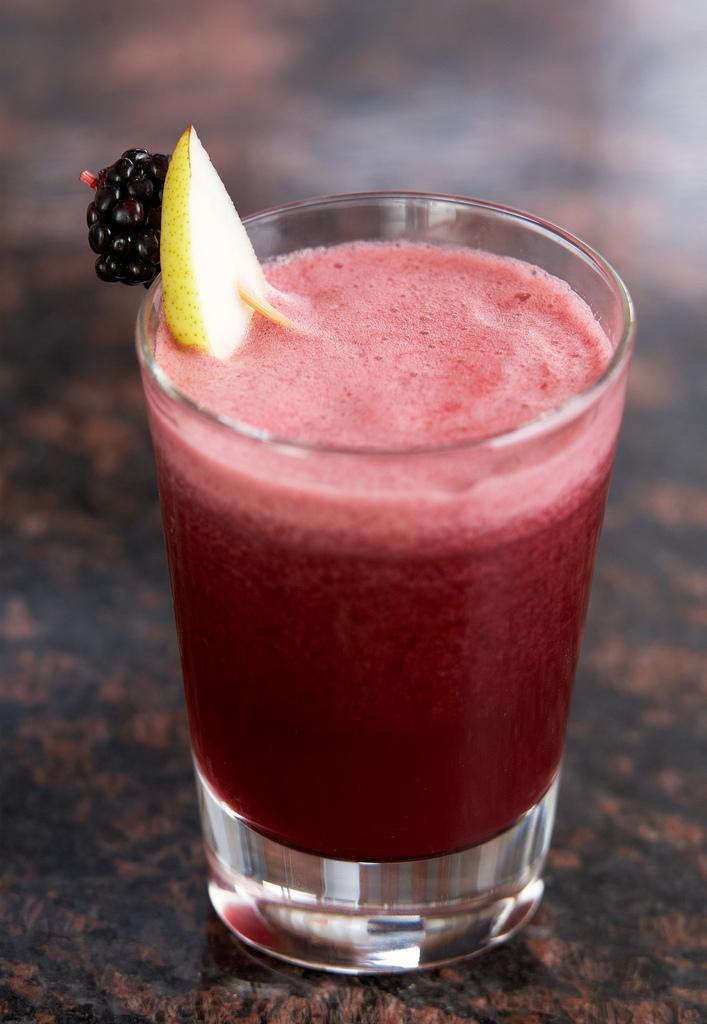Could you give a brief overview of what you see in this image? In this picture we can see a glass with the juice. And these are the fruits. 